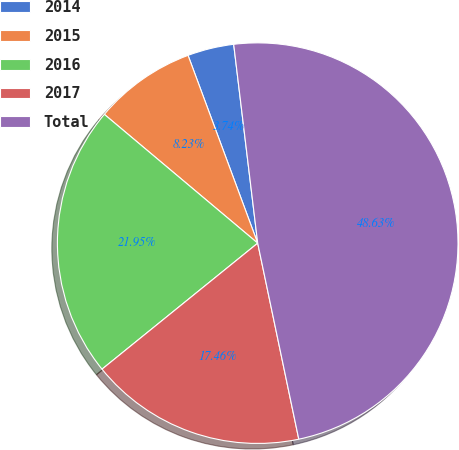Convert chart to OTSL. <chart><loc_0><loc_0><loc_500><loc_500><pie_chart><fcel>2014<fcel>2015<fcel>2016<fcel>2017<fcel>Total<nl><fcel>3.74%<fcel>8.23%<fcel>21.95%<fcel>17.46%<fcel>48.63%<nl></chart> 